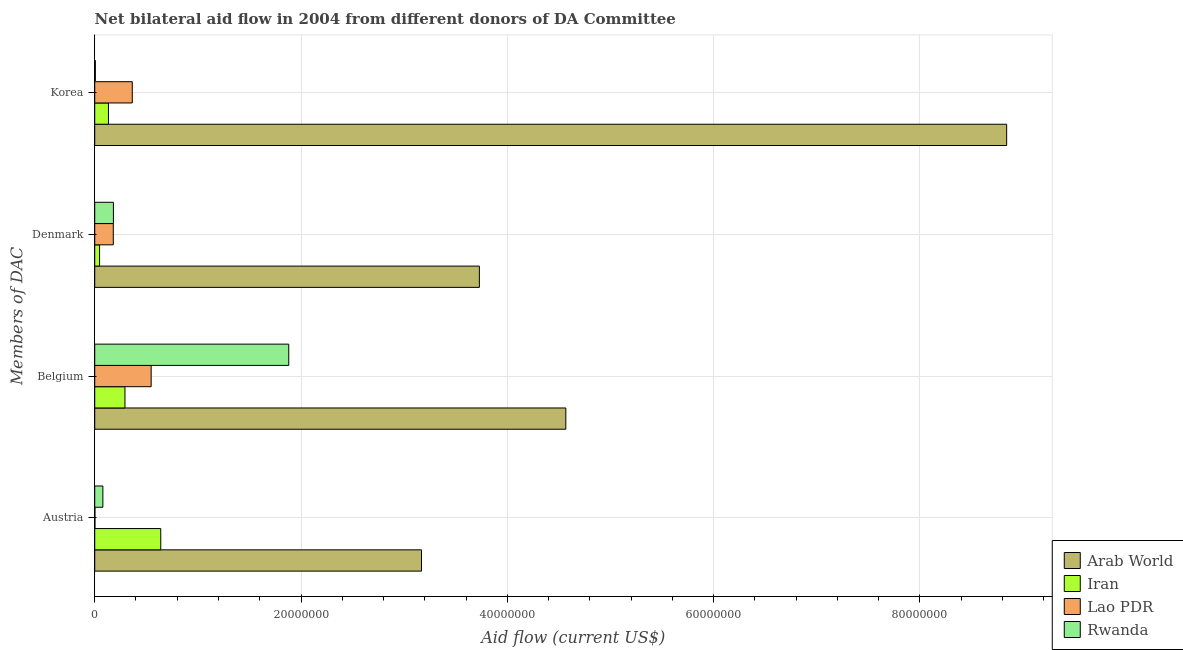How many different coloured bars are there?
Give a very brief answer. 4. How many bars are there on the 3rd tick from the top?
Keep it short and to the point. 4. What is the label of the 2nd group of bars from the top?
Your answer should be very brief. Denmark. What is the amount of aid given by korea in Rwanda?
Offer a very short reply. 6.00e+04. Across all countries, what is the maximum amount of aid given by belgium?
Ensure brevity in your answer.  4.57e+07. Across all countries, what is the minimum amount of aid given by denmark?
Provide a succinct answer. 4.70e+05. In which country was the amount of aid given by austria maximum?
Ensure brevity in your answer.  Arab World. In which country was the amount of aid given by denmark minimum?
Your answer should be very brief. Iran. What is the total amount of aid given by austria in the graph?
Ensure brevity in your answer.  3.89e+07. What is the difference between the amount of aid given by austria in Rwanda and that in Lao PDR?
Your response must be concise. 7.70e+05. What is the difference between the amount of aid given by belgium in Arab World and the amount of aid given by denmark in Rwanda?
Provide a short and direct response. 4.39e+07. What is the average amount of aid given by denmark per country?
Give a very brief answer. 1.03e+07. What is the difference between the amount of aid given by austria and amount of aid given by belgium in Arab World?
Keep it short and to the point. -1.40e+07. In how many countries, is the amount of aid given by austria greater than 80000000 US$?
Make the answer very short. 0. What is the ratio of the amount of aid given by denmark in Rwanda to that in Lao PDR?
Your answer should be very brief. 1.01. Is the amount of aid given by korea in Iran less than that in Arab World?
Keep it short and to the point. Yes. Is the difference between the amount of aid given by korea in Arab World and Iran greater than the difference between the amount of aid given by belgium in Arab World and Iran?
Your response must be concise. Yes. What is the difference between the highest and the second highest amount of aid given by belgium?
Make the answer very short. 2.69e+07. What is the difference between the highest and the lowest amount of aid given by denmark?
Ensure brevity in your answer.  3.68e+07. In how many countries, is the amount of aid given by belgium greater than the average amount of aid given by belgium taken over all countries?
Keep it short and to the point. 2. Is the sum of the amount of aid given by korea in Rwanda and Iran greater than the maximum amount of aid given by belgium across all countries?
Ensure brevity in your answer.  No. Is it the case that in every country, the sum of the amount of aid given by denmark and amount of aid given by austria is greater than the sum of amount of aid given by korea and amount of aid given by belgium?
Provide a short and direct response. No. What does the 1st bar from the top in Belgium represents?
Make the answer very short. Rwanda. What does the 2nd bar from the bottom in Belgium represents?
Keep it short and to the point. Iran. Is it the case that in every country, the sum of the amount of aid given by austria and amount of aid given by belgium is greater than the amount of aid given by denmark?
Offer a terse response. Yes. How many bars are there?
Your answer should be compact. 16. What is the difference between two consecutive major ticks on the X-axis?
Ensure brevity in your answer.  2.00e+07. Are the values on the major ticks of X-axis written in scientific E-notation?
Your answer should be very brief. No. Does the graph contain any zero values?
Your response must be concise. No. Does the graph contain grids?
Keep it short and to the point. Yes. Where does the legend appear in the graph?
Give a very brief answer. Bottom right. What is the title of the graph?
Your answer should be compact. Net bilateral aid flow in 2004 from different donors of DA Committee. What is the label or title of the X-axis?
Offer a very short reply. Aid flow (current US$). What is the label or title of the Y-axis?
Offer a very short reply. Members of DAC. What is the Aid flow (current US$) in Arab World in Austria?
Make the answer very short. 3.17e+07. What is the Aid flow (current US$) in Iran in Austria?
Your answer should be compact. 6.40e+06. What is the Aid flow (current US$) of Rwanda in Austria?
Give a very brief answer. 7.90e+05. What is the Aid flow (current US$) of Arab World in Belgium?
Make the answer very short. 4.57e+07. What is the Aid flow (current US$) in Iran in Belgium?
Your response must be concise. 2.93e+06. What is the Aid flow (current US$) in Lao PDR in Belgium?
Provide a short and direct response. 5.47e+06. What is the Aid flow (current US$) in Rwanda in Belgium?
Provide a short and direct response. 1.88e+07. What is the Aid flow (current US$) in Arab World in Denmark?
Provide a short and direct response. 3.73e+07. What is the Aid flow (current US$) in Iran in Denmark?
Provide a short and direct response. 4.70e+05. What is the Aid flow (current US$) of Lao PDR in Denmark?
Your answer should be very brief. 1.80e+06. What is the Aid flow (current US$) in Rwanda in Denmark?
Provide a succinct answer. 1.81e+06. What is the Aid flow (current US$) of Arab World in Korea?
Provide a succinct answer. 8.84e+07. What is the Aid flow (current US$) in Iran in Korea?
Provide a succinct answer. 1.33e+06. What is the Aid flow (current US$) in Lao PDR in Korea?
Keep it short and to the point. 3.64e+06. What is the Aid flow (current US$) in Rwanda in Korea?
Give a very brief answer. 6.00e+04. Across all Members of DAC, what is the maximum Aid flow (current US$) of Arab World?
Offer a very short reply. 8.84e+07. Across all Members of DAC, what is the maximum Aid flow (current US$) of Iran?
Offer a very short reply. 6.40e+06. Across all Members of DAC, what is the maximum Aid flow (current US$) in Lao PDR?
Your response must be concise. 5.47e+06. Across all Members of DAC, what is the maximum Aid flow (current US$) of Rwanda?
Offer a very short reply. 1.88e+07. Across all Members of DAC, what is the minimum Aid flow (current US$) in Arab World?
Provide a short and direct response. 3.17e+07. Across all Members of DAC, what is the minimum Aid flow (current US$) in Iran?
Your answer should be compact. 4.70e+05. Across all Members of DAC, what is the minimum Aid flow (current US$) of Lao PDR?
Offer a very short reply. 2.00e+04. What is the total Aid flow (current US$) of Arab World in the graph?
Offer a very short reply. 2.03e+08. What is the total Aid flow (current US$) of Iran in the graph?
Provide a succinct answer. 1.11e+07. What is the total Aid flow (current US$) in Lao PDR in the graph?
Keep it short and to the point. 1.09e+07. What is the total Aid flow (current US$) in Rwanda in the graph?
Offer a terse response. 2.15e+07. What is the difference between the Aid flow (current US$) of Arab World in Austria and that in Belgium?
Your answer should be compact. -1.40e+07. What is the difference between the Aid flow (current US$) of Iran in Austria and that in Belgium?
Give a very brief answer. 3.47e+06. What is the difference between the Aid flow (current US$) of Lao PDR in Austria and that in Belgium?
Your response must be concise. -5.45e+06. What is the difference between the Aid flow (current US$) of Rwanda in Austria and that in Belgium?
Your response must be concise. -1.80e+07. What is the difference between the Aid flow (current US$) of Arab World in Austria and that in Denmark?
Ensure brevity in your answer.  -5.61e+06. What is the difference between the Aid flow (current US$) of Iran in Austria and that in Denmark?
Offer a very short reply. 5.93e+06. What is the difference between the Aid flow (current US$) of Lao PDR in Austria and that in Denmark?
Your answer should be compact. -1.78e+06. What is the difference between the Aid flow (current US$) in Rwanda in Austria and that in Denmark?
Offer a very short reply. -1.02e+06. What is the difference between the Aid flow (current US$) of Arab World in Austria and that in Korea?
Your response must be concise. -5.67e+07. What is the difference between the Aid flow (current US$) in Iran in Austria and that in Korea?
Your response must be concise. 5.07e+06. What is the difference between the Aid flow (current US$) of Lao PDR in Austria and that in Korea?
Offer a terse response. -3.62e+06. What is the difference between the Aid flow (current US$) in Rwanda in Austria and that in Korea?
Make the answer very short. 7.30e+05. What is the difference between the Aid flow (current US$) of Arab World in Belgium and that in Denmark?
Keep it short and to the point. 8.38e+06. What is the difference between the Aid flow (current US$) in Iran in Belgium and that in Denmark?
Your answer should be very brief. 2.46e+06. What is the difference between the Aid flow (current US$) in Lao PDR in Belgium and that in Denmark?
Your answer should be compact. 3.67e+06. What is the difference between the Aid flow (current US$) of Rwanda in Belgium and that in Denmark?
Offer a terse response. 1.70e+07. What is the difference between the Aid flow (current US$) of Arab World in Belgium and that in Korea?
Your answer should be compact. -4.27e+07. What is the difference between the Aid flow (current US$) in Iran in Belgium and that in Korea?
Make the answer very short. 1.60e+06. What is the difference between the Aid flow (current US$) of Lao PDR in Belgium and that in Korea?
Keep it short and to the point. 1.83e+06. What is the difference between the Aid flow (current US$) of Rwanda in Belgium and that in Korea?
Your answer should be very brief. 1.88e+07. What is the difference between the Aid flow (current US$) in Arab World in Denmark and that in Korea?
Offer a very short reply. -5.11e+07. What is the difference between the Aid flow (current US$) in Iran in Denmark and that in Korea?
Your answer should be very brief. -8.60e+05. What is the difference between the Aid flow (current US$) in Lao PDR in Denmark and that in Korea?
Provide a short and direct response. -1.84e+06. What is the difference between the Aid flow (current US$) in Rwanda in Denmark and that in Korea?
Provide a short and direct response. 1.75e+06. What is the difference between the Aid flow (current US$) in Arab World in Austria and the Aid flow (current US$) in Iran in Belgium?
Provide a succinct answer. 2.88e+07. What is the difference between the Aid flow (current US$) of Arab World in Austria and the Aid flow (current US$) of Lao PDR in Belgium?
Offer a terse response. 2.62e+07. What is the difference between the Aid flow (current US$) of Arab World in Austria and the Aid flow (current US$) of Rwanda in Belgium?
Ensure brevity in your answer.  1.29e+07. What is the difference between the Aid flow (current US$) in Iran in Austria and the Aid flow (current US$) in Lao PDR in Belgium?
Your answer should be compact. 9.30e+05. What is the difference between the Aid flow (current US$) of Iran in Austria and the Aid flow (current US$) of Rwanda in Belgium?
Offer a very short reply. -1.24e+07. What is the difference between the Aid flow (current US$) of Lao PDR in Austria and the Aid flow (current US$) of Rwanda in Belgium?
Offer a very short reply. -1.88e+07. What is the difference between the Aid flow (current US$) of Arab World in Austria and the Aid flow (current US$) of Iran in Denmark?
Keep it short and to the point. 3.12e+07. What is the difference between the Aid flow (current US$) of Arab World in Austria and the Aid flow (current US$) of Lao PDR in Denmark?
Your answer should be very brief. 2.99e+07. What is the difference between the Aid flow (current US$) in Arab World in Austria and the Aid flow (current US$) in Rwanda in Denmark?
Offer a terse response. 2.99e+07. What is the difference between the Aid flow (current US$) in Iran in Austria and the Aid flow (current US$) in Lao PDR in Denmark?
Your response must be concise. 4.60e+06. What is the difference between the Aid flow (current US$) of Iran in Austria and the Aid flow (current US$) of Rwanda in Denmark?
Offer a terse response. 4.59e+06. What is the difference between the Aid flow (current US$) of Lao PDR in Austria and the Aid flow (current US$) of Rwanda in Denmark?
Your answer should be very brief. -1.79e+06. What is the difference between the Aid flow (current US$) in Arab World in Austria and the Aid flow (current US$) in Iran in Korea?
Keep it short and to the point. 3.04e+07. What is the difference between the Aid flow (current US$) of Arab World in Austria and the Aid flow (current US$) of Lao PDR in Korea?
Make the answer very short. 2.80e+07. What is the difference between the Aid flow (current US$) of Arab World in Austria and the Aid flow (current US$) of Rwanda in Korea?
Provide a short and direct response. 3.16e+07. What is the difference between the Aid flow (current US$) in Iran in Austria and the Aid flow (current US$) in Lao PDR in Korea?
Offer a very short reply. 2.76e+06. What is the difference between the Aid flow (current US$) in Iran in Austria and the Aid flow (current US$) in Rwanda in Korea?
Your answer should be compact. 6.34e+06. What is the difference between the Aid flow (current US$) in Lao PDR in Austria and the Aid flow (current US$) in Rwanda in Korea?
Ensure brevity in your answer.  -4.00e+04. What is the difference between the Aid flow (current US$) of Arab World in Belgium and the Aid flow (current US$) of Iran in Denmark?
Provide a short and direct response. 4.52e+07. What is the difference between the Aid flow (current US$) of Arab World in Belgium and the Aid flow (current US$) of Lao PDR in Denmark?
Provide a succinct answer. 4.39e+07. What is the difference between the Aid flow (current US$) of Arab World in Belgium and the Aid flow (current US$) of Rwanda in Denmark?
Your response must be concise. 4.39e+07. What is the difference between the Aid flow (current US$) of Iran in Belgium and the Aid flow (current US$) of Lao PDR in Denmark?
Provide a short and direct response. 1.13e+06. What is the difference between the Aid flow (current US$) of Iran in Belgium and the Aid flow (current US$) of Rwanda in Denmark?
Give a very brief answer. 1.12e+06. What is the difference between the Aid flow (current US$) in Lao PDR in Belgium and the Aid flow (current US$) in Rwanda in Denmark?
Keep it short and to the point. 3.66e+06. What is the difference between the Aid flow (current US$) of Arab World in Belgium and the Aid flow (current US$) of Iran in Korea?
Your answer should be compact. 4.43e+07. What is the difference between the Aid flow (current US$) in Arab World in Belgium and the Aid flow (current US$) in Lao PDR in Korea?
Keep it short and to the point. 4.20e+07. What is the difference between the Aid flow (current US$) of Arab World in Belgium and the Aid flow (current US$) of Rwanda in Korea?
Make the answer very short. 4.56e+07. What is the difference between the Aid flow (current US$) in Iran in Belgium and the Aid flow (current US$) in Lao PDR in Korea?
Your response must be concise. -7.10e+05. What is the difference between the Aid flow (current US$) of Iran in Belgium and the Aid flow (current US$) of Rwanda in Korea?
Offer a very short reply. 2.87e+06. What is the difference between the Aid flow (current US$) of Lao PDR in Belgium and the Aid flow (current US$) of Rwanda in Korea?
Offer a terse response. 5.41e+06. What is the difference between the Aid flow (current US$) in Arab World in Denmark and the Aid flow (current US$) in Iran in Korea?
Offer a very short reply. 3.60e+07. What is the difference between the Aid flow (current US$) in Arab World in Denmark and the Aid flow (current US$) in Lao PDR in Korea?
Offer a terse response. 3.36e+07. What is the difference between the Aid flow (current US$) in Arab World in Denmark and the Aid flow (current US$) in Rwanda in Korea?
Your answer should be very brief. 3.72e+07. What is the difference between the Aid flow (current US$) in Iran in Denmark and the Aid flow (current US$) in Lao PDR in Korea?
Provide a succinct answer. -3.17e+06. What is the difference between the Aid flow (current US$) in Lao PDR in Denmark and the Aid flow (current US$) in Rwanda in Korea?
Offer a terse response. 1.74e+06. What is the average Aid flow (current US$) of Arab World per Members of DAC?
Offer a very short reply. 5.08e+07. What is the average Aid flow (current US$) of Iran per Members of DAC?
Your answer should be very brief. 2.78e+06. What is the average Aid flow (current US$) in Lao PDR per Members of DAC?
Provide a succinct answer. 2.73e+06. What is the average Aid flow (current US$) of Rwanda per Members of DAC?
Offer a terse response. 5.37e+06. What is the difference between the Aid flow (current US$) of Arab World and Aid flow (current US$) of Iran in Austria?
Your answer should be compact. 2.53e+07. What is the difference between the Aid flow (current US$) of Arab World and Aid flow (current US$) of Lao PDR in Austria?
Provide a short and direct response. 3.17e+07. What is the difference between the Aid flow (current US$) of Arab World and Aid flow (current US$) of Rwanda in Austria?
Offer a terse response. 3.09e+07. What is the difference between the Aid flow (current US$) in Iran and Aid flow (current US$) in Lao PDR in Austria?
Provide a short and direct response. 6.38e+06. What is the difference between the Aid flow (current US$) in Iran and Aid flow (current US$) in Rwanda in Austria?
Provide a succinct answer. 5.61e+06. What is the difference between the Aid flow (current US$) of Lao PDR and Aid flow (current US$) of Rwanda in Austria?
Provide a short and direct response. -7.70e+05. What is the difference between the Aid flow (current US$) in Arab World and Aid flow (current US$) in Iran in Belgium?
Keep it short and to the point. 4.27e+07. What is the difference between the Aid flow (current US$) of Arab World and Aid flow (current US$) of Lao PDR in Belgium?
Your answer should be very brief. 4.02e+07. What is the difference between the Aid flow (current US$) of Arab World and Aid flow (current US$) of Rwanda in Belgium?
Your answer should be compact. 2.69e+07. What is the difference between the Aid flow (current US$) of Iran and Aid flow (current US$) of Lao PDR in Belgium?
Make the answer very short. -2.54e+06. What is the difference between the Aid flow (current US$) of Iran and Aid flow (current US$) of Rwanda in Belgium?
Provide a succinct answer. -1.59e+07. What is the difference between the Aid flow (current US$) in Lao PDR and Aid flow (current US$) in Rwanda in Belgium?
Your answer should be very brief. -1.33e+07. What is the difference between the Aid flow (current US$) in Arab World and Aid flow (current US$) in Iran in Denmark?
Give a very brief answer. 3.68e+07. What is the difference between the Aid flow (current US$) of Arab World and Aid flow (current US$) of Lao PDR in Denmark?
Offer a very short reply. 3.55e+07. What is the difference between the Aid flow (current US$) of Arab World and Aid flow (current US$) of Rwanda in Denmark?
Your response must be concise. 3.55e+07. What is the difference between the Aid flow (current US$) of Iran and Aid flow (current US$) of Lao PDR in Denmark?
Ensure brevity in your answer.  -1.33e+06. What is the difference between the Aid flow (current US$) of Iran and Aid flow (current US$) of Rwanda in Denmark?
Keep it short and to the point. -1.34e+06. What is the difference between the Aid flow (current US$) of Lao PDR and Aid flow (current US$) of Rwanda in Denmark?
Provide a succinct answer. -10000. What is the difference between the Aid flow (current US$) in Arab World and Aid flow (current US$) in Iran in Korea?
Make the answer very short. 8.71e+07. What is the difference between the Aid flow (current US$) in Arab World and Aid flow (current US$) in Lao PDR in Korea?
Your response must be concise. 8.48e+07. What is the difference between the Aid flow (current US$) of Arab World and Aid flow (current US$) of Rwanda in Korea?
Provide a short and direct response. 8.84e+07. What is the difference between the Aid flow (current US$) of Iran and Aid flow (current US$) of Lao PDR in Korea?
Give a very brief answer. -2.31e+06. What is the difference between the Aid flow (current US$) in Iran and Aid flow (current US$) in Rwanda in Korea?
Offer a very short reply. 1.27e+06. What is the difference between the Aid flow (current US$) of Lao PDR and Aid flow (current US$) of Rwanda in Korea?
Make the answer very short. 3.58e+06. What is the ratio of the Aid flow (current US$) of Arab World in Austria to that in Belgium?
Make the answer very short. 0.69. What is the ratio of the Aid flow (current US$) in Iran in Austria to that in Belgium?
Offer a very short reply. 2.18. What is the ratio of the Aid flow (current US$) in Lao PDR in Austria to that in Belgium?
Make the answer very short. 0. What is the ratio of the Aid flow (current US$) in Rwanda in Austria to that in Belgium?
Give a very brief answer. 0.04. What is the ratio of the Aid flow (current US$) of Arab World in Austria to that in Denmark?
Offer a very short reply. 0.85. What is the ratio of the Aid flow (current US$) of Iran in Austria to that in Denmark?
Keep it short and to the point. 13.62. What is the ratio of the Aid flow (current US$) in Lao PDR in Austria to that in Denmark?
Provide a short and direct response. 0.01. What is the ratio of the Aid flow (current US$) of Rwanda in Austria to that in Denmark?
Offer a very short reply. 0.44. What is the ratio of the Aid flow (current US$) in Arab World in Austria to that in Korea?
Provide a short and direct response. 0.36. What is the ratio of the Aid flow (current US$) in Iran in Austria to that in Korea?
Keep it short and to the point. 4.81. What is the ratio of the Aid flow (current US$) of Lao PDR in Austria to that in Korea?
Make the answer very short. 0.01. What is the ratio of the Aid flow (current US$) in Rwanda in Austria to that in Korea?
Offer a terse response. 13.17. What is the ratio of the Aid flow (current US$) of Arab World in Belgium to that in Denmark?
Give a very brief answer. 1.22. What is the ratio of the Aid flow (current US$) of Iran in Belgium to that in Denmark?
Keep it short and to the point. 6.23. What is the ratio of the Aid flow (current US$) of Lao PDR in Belgium to that in Denmark?
Your response must be concise. 3.04. What is the ratio of the Aid flow (current US$) in Rwanda in Belgium to that in Denmark?
Ensure brevity in your answer.  10.39. What is the ratio of the Aid flow (current US$) in Arab World in Belgium to that in Korea?
Offer a terse response. 0.52. What is the ratio of the Aid flow (current US$) in Iran in Belgium to that in Korea?
Keep it short and to the point. 2.2. What is the ratio of the Aid flow (current US$) of Lao PDR in Belgium to that in Korea?
Offer a terse response. 1.5. What is the ratio of the Aid flow (current US$) of Rwanda in Belgium to that in Korea?
Make the answer very short. 313.5. What is the ratio of the Aid flow (current US$) in Arab World in Denmark to that in Korea?
Your answer should be compact. 0.42. What is the ratio of the Aid flow (current US$) of Iran in Denmark to that in Korea?
Your response must be concise. 0.35. What is the ratio of the Aid flow (current US$) of Lao PDR in Denmark to that in Korea?
Give a very brief answer. 0.49. What is the ratio of the Aid flow (current US$) in Rwanda in Denmark to that in Korea?
Make the answer very short. 30.17. What is the difference between the highest and the second highest Aid flow (current US$) of Arab World?
Provide a succinct answer. 4.27e+07. What is the difference between the highest and the second highest Aid flow (current US$) of Iran?
Provide a succinct answer. 3.47e+06. What is the difference between the highest and the second highest Aid flow (current US$) of Lao PDR?
Provide a short and direct response. 1.83e+06. What is the difference between the highest and the second highest Aid flow (current US$) in Rwanda?
Give a very brief answer. 1.70e+07. What is the difference between the highest and the lowest Aid flow (current US$) in Arab World?
Offer a terse response. 5.67e+07. What is the difference between the highest and the lowest Aid flow (current US$) of Iran?
Your response must be concise. 5.93e+06. What is the difference between the highest and the lowest Aid flow (current US$) of Lao PDR?
Your response must be concise. 5.45e+06. What is the difference between the highest and the lowest Aid flow (current US$) of Rwanda?
Make the answer very short. 1.88e+07. 